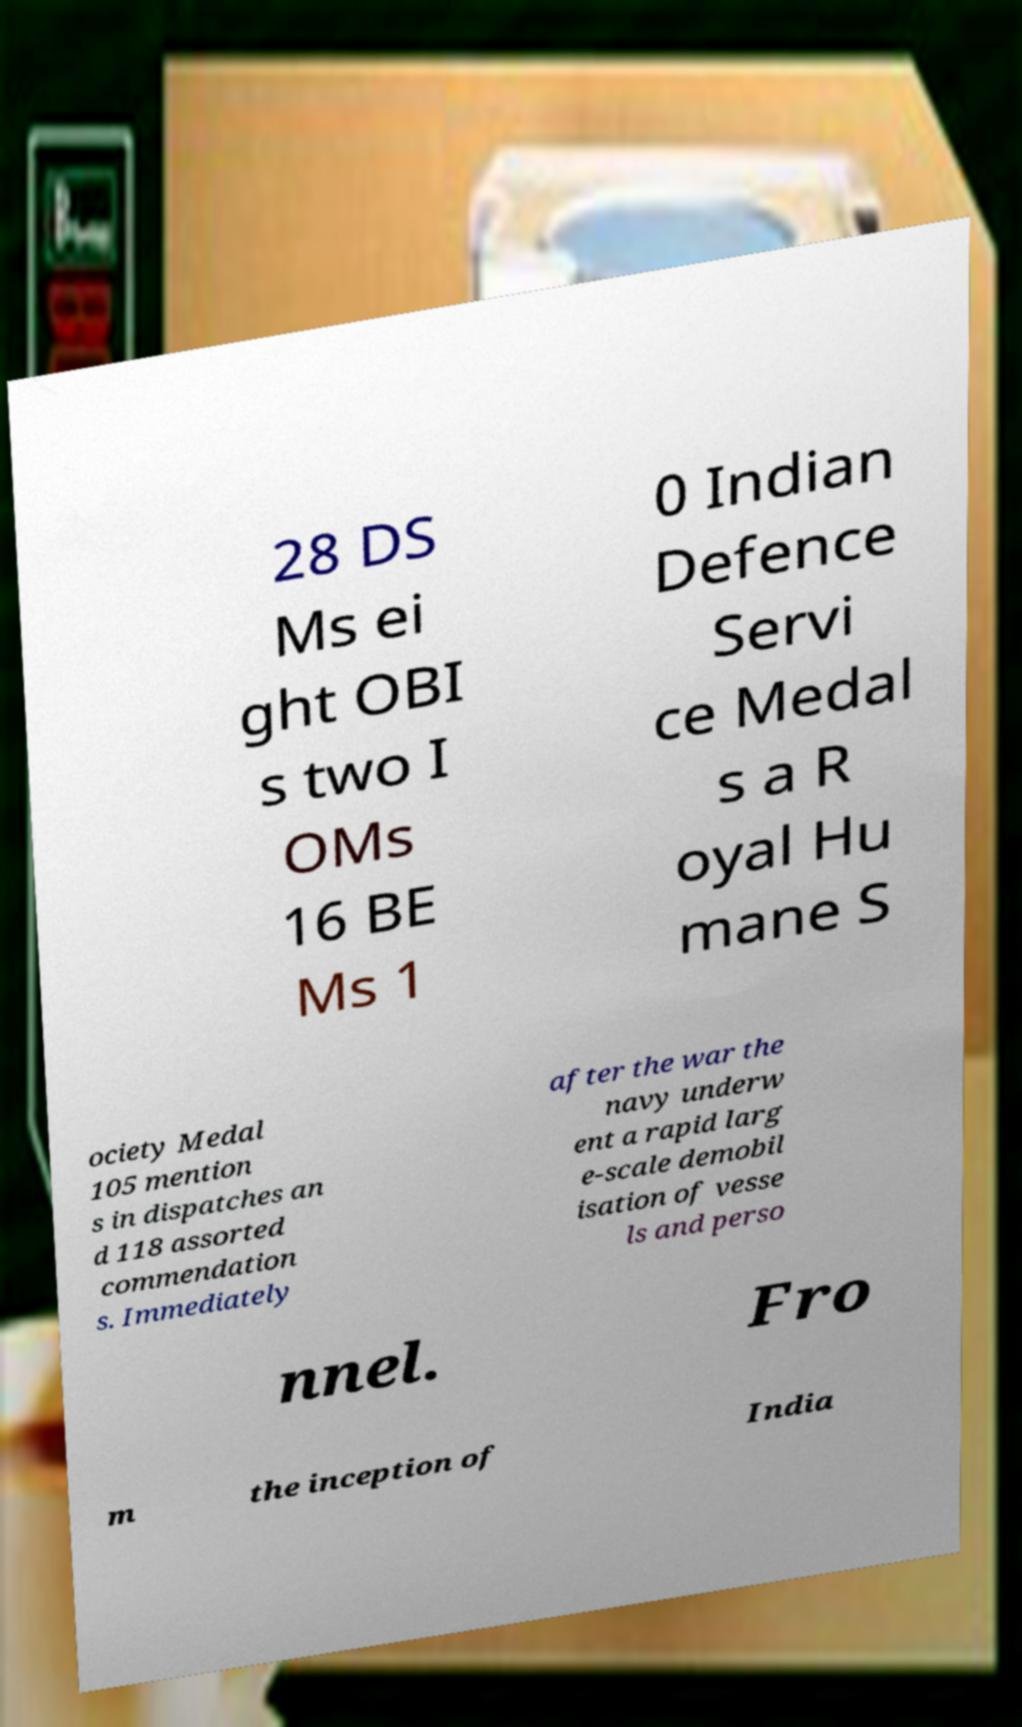Could you assist in decoding the text presented in this image and type it out clearly? 28 DS Ms ei ght OBI s two I OMs 16 BE Ms 1 0 Indian Defence Servi ce Medal s a R oyal Hu mane S ociety Medal 105 mention s in dispatches an d 118 assorted commendation s. Immediately after the war the navy underw ent a rapid larg e-scale demobil isation of vesse ls and perso nnel. Fro m the inception of India 